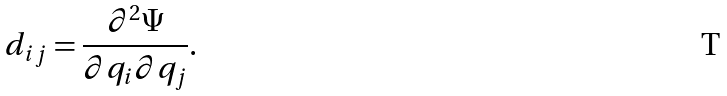Convert formula to latex. <formula><loc_0><loc_0><loc_500><loc_500>d _ { i j } = \frac { \partial ^ { 2 } \Psi } { \partial q _ { i } \partial q _ { j } } .</formula> 